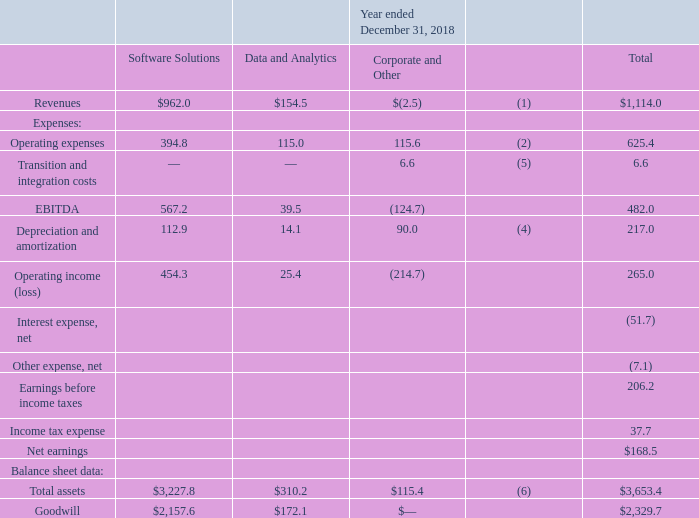Summarized financial information concerning our segments is shown in the tables below (in millions):
(1) Revenues for Corporate and Other represent deferred revenue purchase accounting adjustments recorded in accordance with GAAP.
(2) Operating expenses for Corporate and Other includes equity-based compensation, including certain related payroll taxes, of $51.7 million, $51.4 million and $19.2 million for the years ended December 31, 2019, 2018 and 2017, respectively.
(4) Depreciation and amortization for Corporate and Other primarily represents net incremental depreciation and amortization adjustments associated with the application of purchase accounting recorded in accordance with GAAP.
(5) Transition and integration costs primarily consists of costs associated with executive transition, transition-related costs as we transferred certain corporate functions from FNF and acquisitions.
(6) Receivables from related parties are included in Corporate and Other.
What did revenues for Corporate and Other represent? Deferred revenue purchase accounting adjustments recorded in accordance with gaap. What were the operating expenses for Software Solutions?
Answer scale should be: million. 394.8. What were the total Transition and integration costs?
Answer scale should be: million. 6.6. What was the difference in the EBITDA between Software Solutions and Data and Analytics?
Answer scale should be: million. 567.2-39.5
Answer: 527.7. What was the difference between Total Assets and Total Goodwill?
Answer scale should be: million. 3,653.4-2,329.7
Answer: 1323.7. What was the difference in Depreciation and amortization between Software Solutions and Corporate and Other?
Answer scale should be: million. 112.9-90.0
Answer: 22.9. 